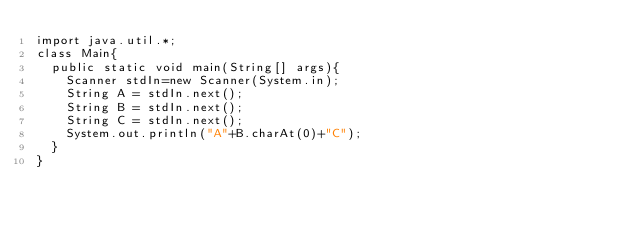Convert code to text. <code><loc_0><loc_0><loc_500><loc_500><_Java_>import java.util.*;
class Main{
  public static void main(String[] args){
    Scanner stdIn=new Scanner(System.in);
    String A = stdIn.next();
    String B = stdIn.next();
    String C = stdIn.next();
    System.out.println("A"+B.charAt(0)+"C");
  }
}
    </code> 